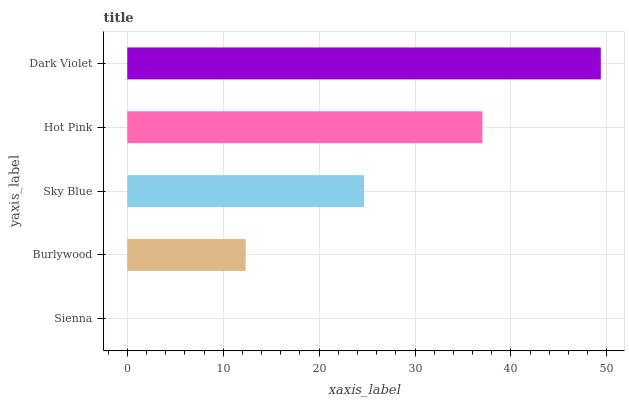Is Sienna the minimum?
Answer yes or no. Yes. Is Dark Violet the maximum?
Answer yes or no. Yes. Is Burlywood the minimum?
Answer yes or no. No. Is Burlywood the maximum?
Answer yes or no. No. Is Burlywood greater than Sienna?
Answer yes or no. Yes. Is Sienna less than Burlywood?
Answer yes or no. Yes. Is Sienna greater than Burlywood?
Answer yes or no. No. Is Burlywood less than Sienna?
Answer yes or no. No. Is Sky Blue the high median?
Answer yes or no. Yes. Is Sky Blue the low median?
Answer yes or no. Yes. Is Hot Pink the high median?
Answer yes or no. No. Is Burlywood the low median?
Answer yes or no. No. 